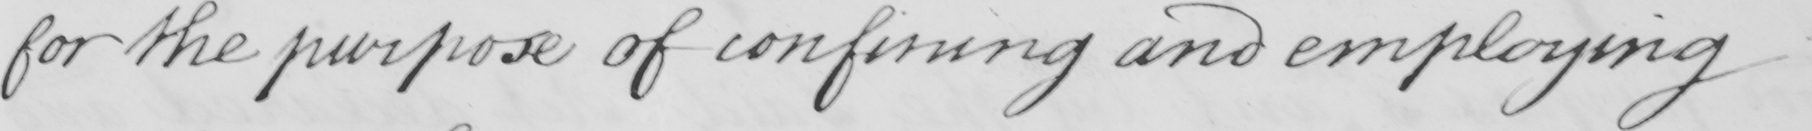What is written in this line of handwriting? for the purpose of confining and employing 